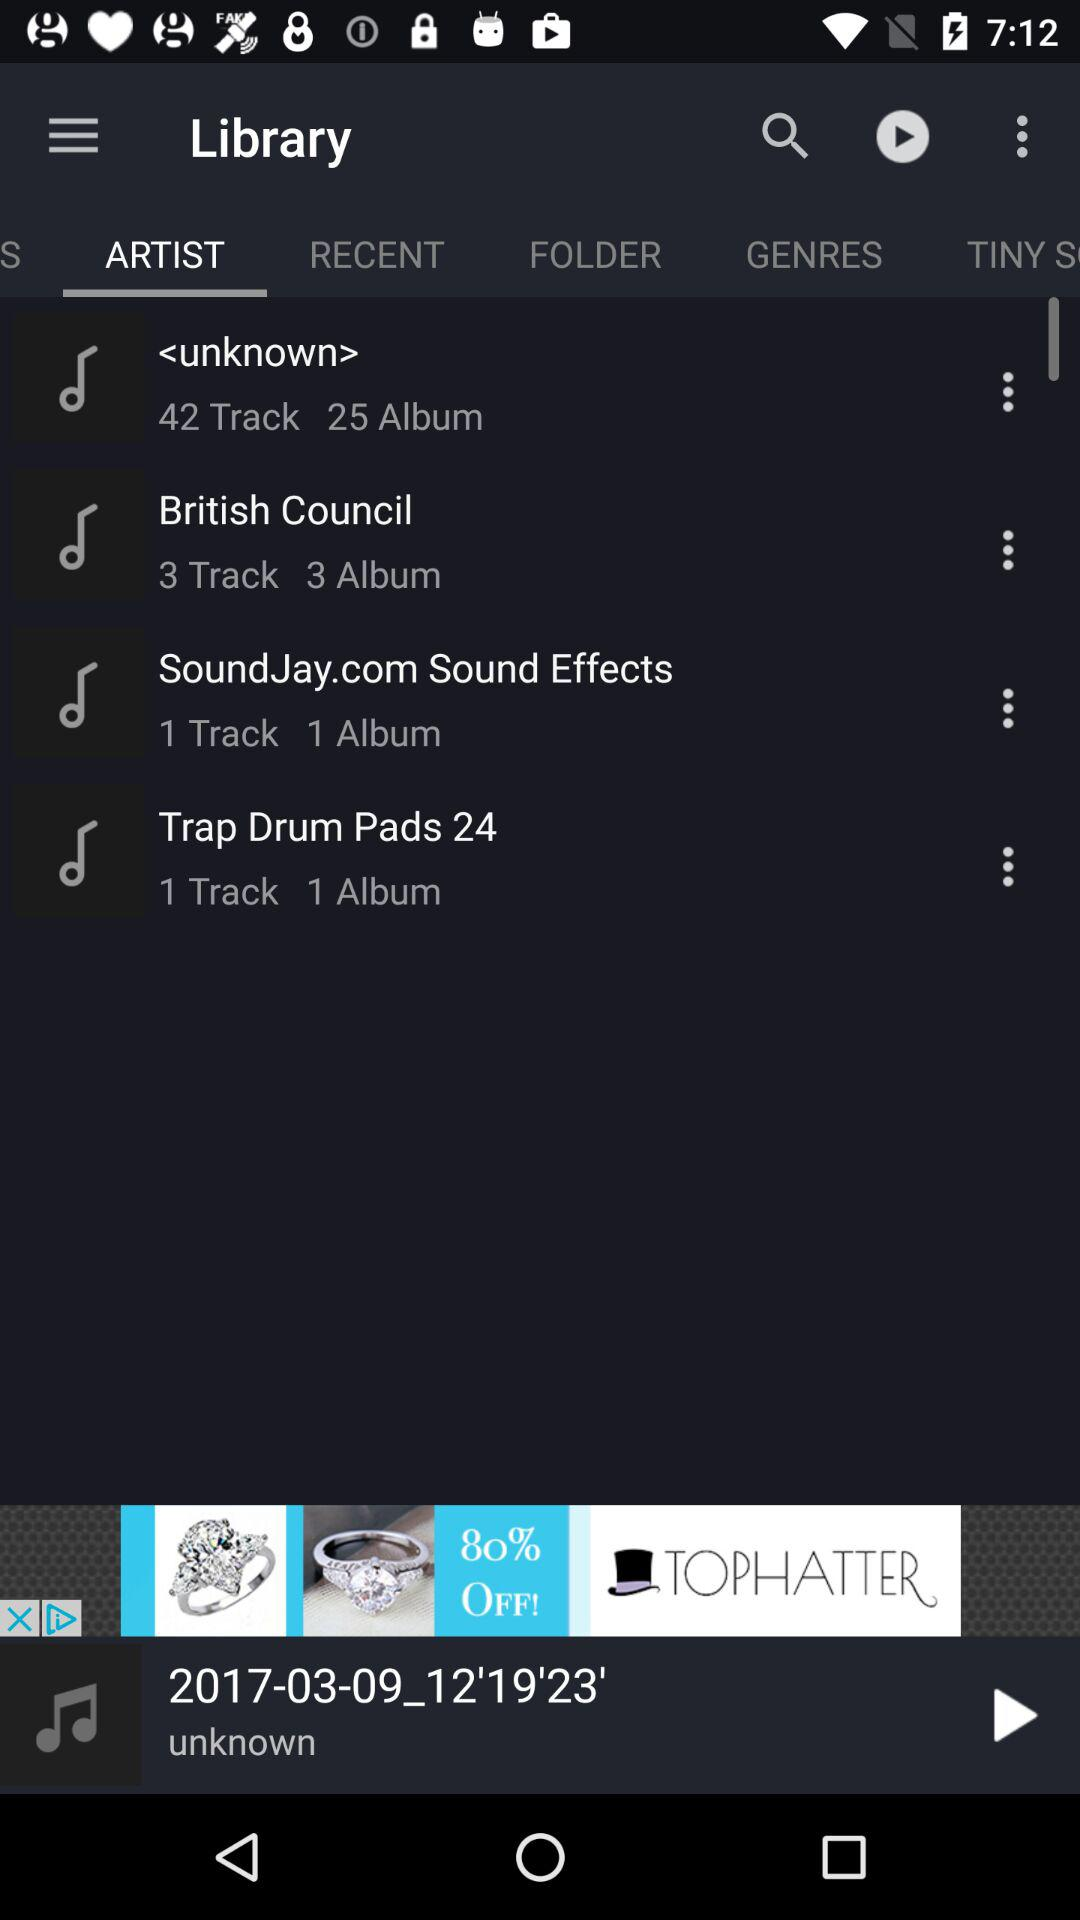How many tracks and albums are available by the British Council? There are 3 tracks and 3 albums available by the British Council. 